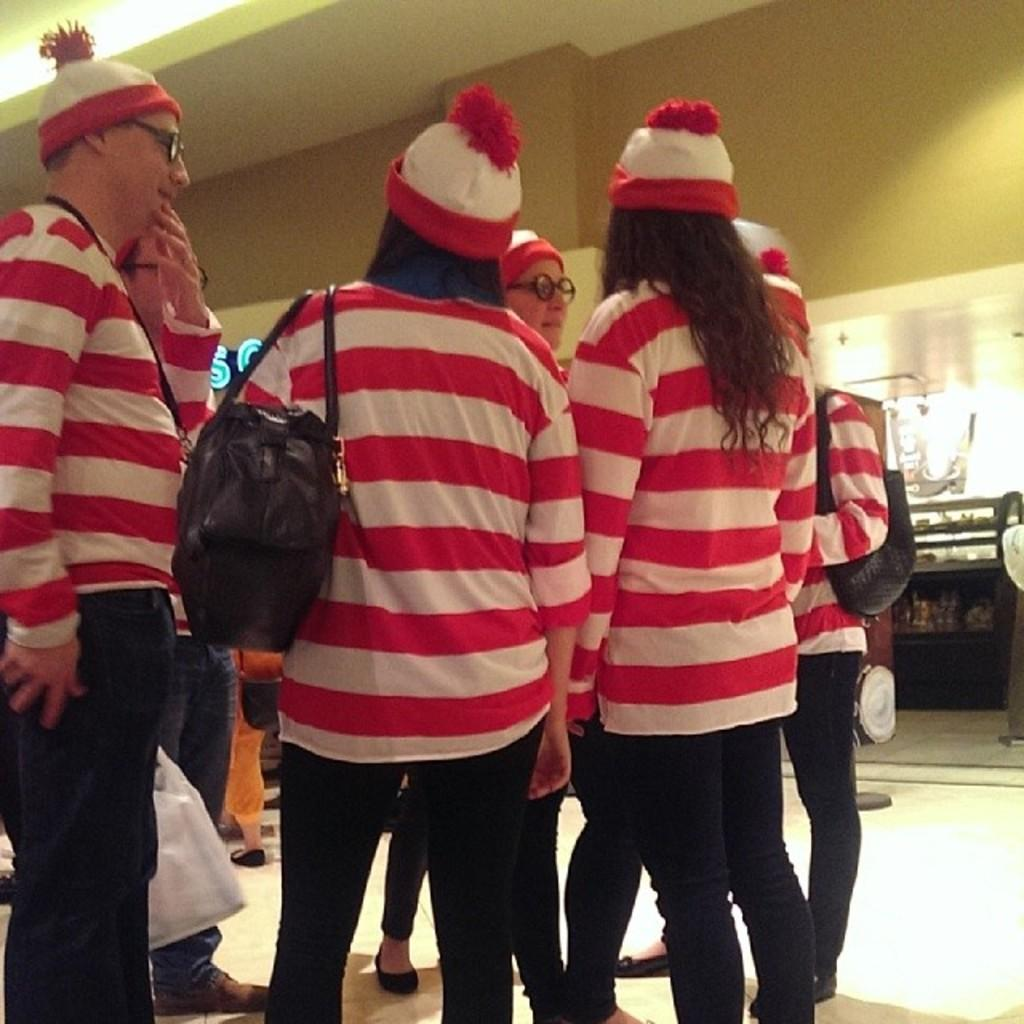What is the main subject of the image? The main subject of the image is a group of people in the foreground. What is the position of the people in relation to the floor? The people are standing on the floor. What are the people wearing that is visible in the image? The people are wearing bags. What can be seen in the background of the image? There is a wall and a table in the background of the image. Can you describe the setting where the image might have been taken? The image may have been taken in a hall, based on the presence of a wall and a table in the background. What type of force is being applied to the sheet in the image? There is no sheet present in the image, so it is not possible to determine if any force is being applied to it. 